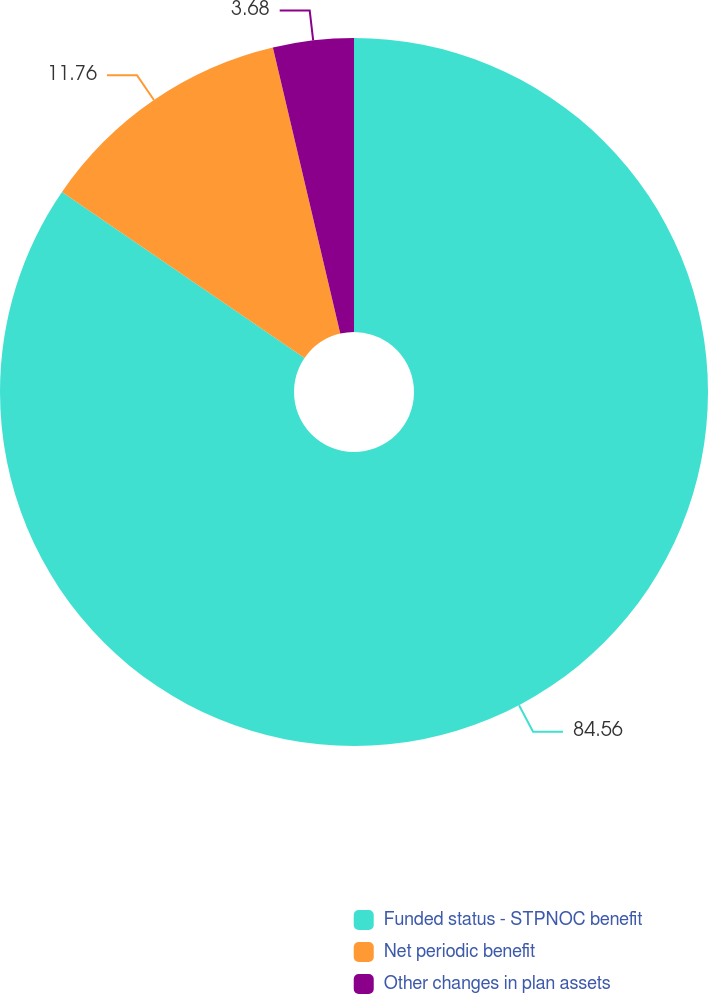Convert chart to OTSL. <chart><loc_0><loc_0><loc_500><loc_500><pie_chart><fcel>Funded status - STPNOC benefit<fcel>Net periodic benefit<fcel>Other changes in plan assets<nl><fcel>84.56%<fcel>11.76%<fcel>3.68%<nl></chart> 